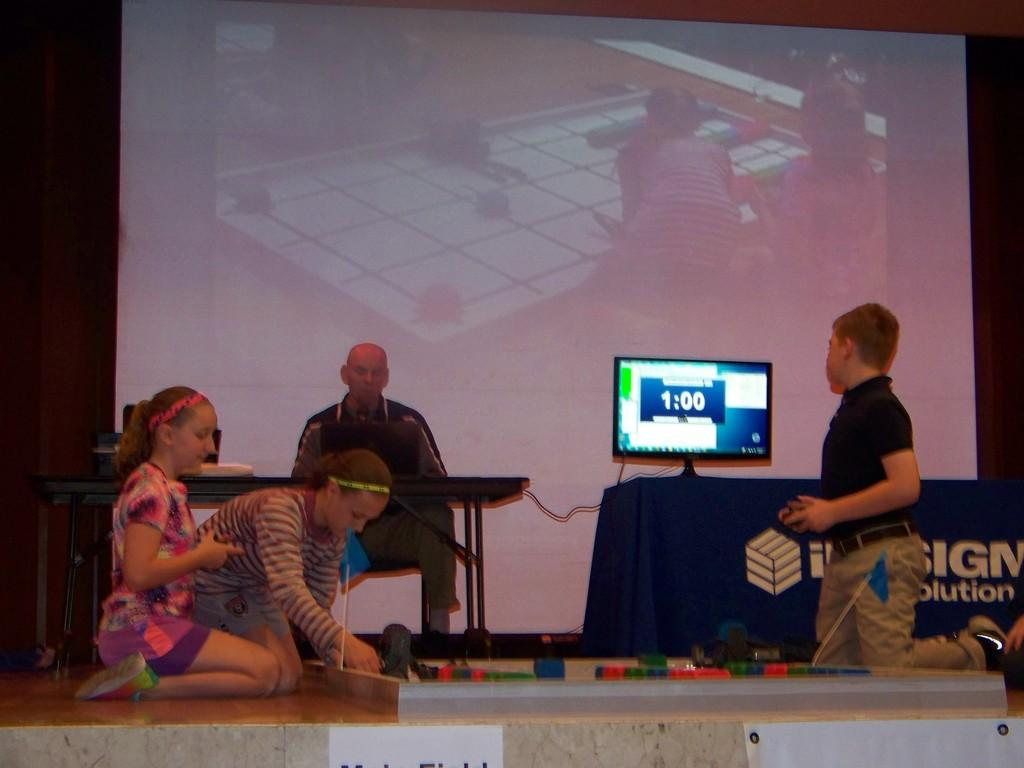<image>
Create a compact narrative representing the image presented. The kids are building blocks in a competition while they only have  minute left. 